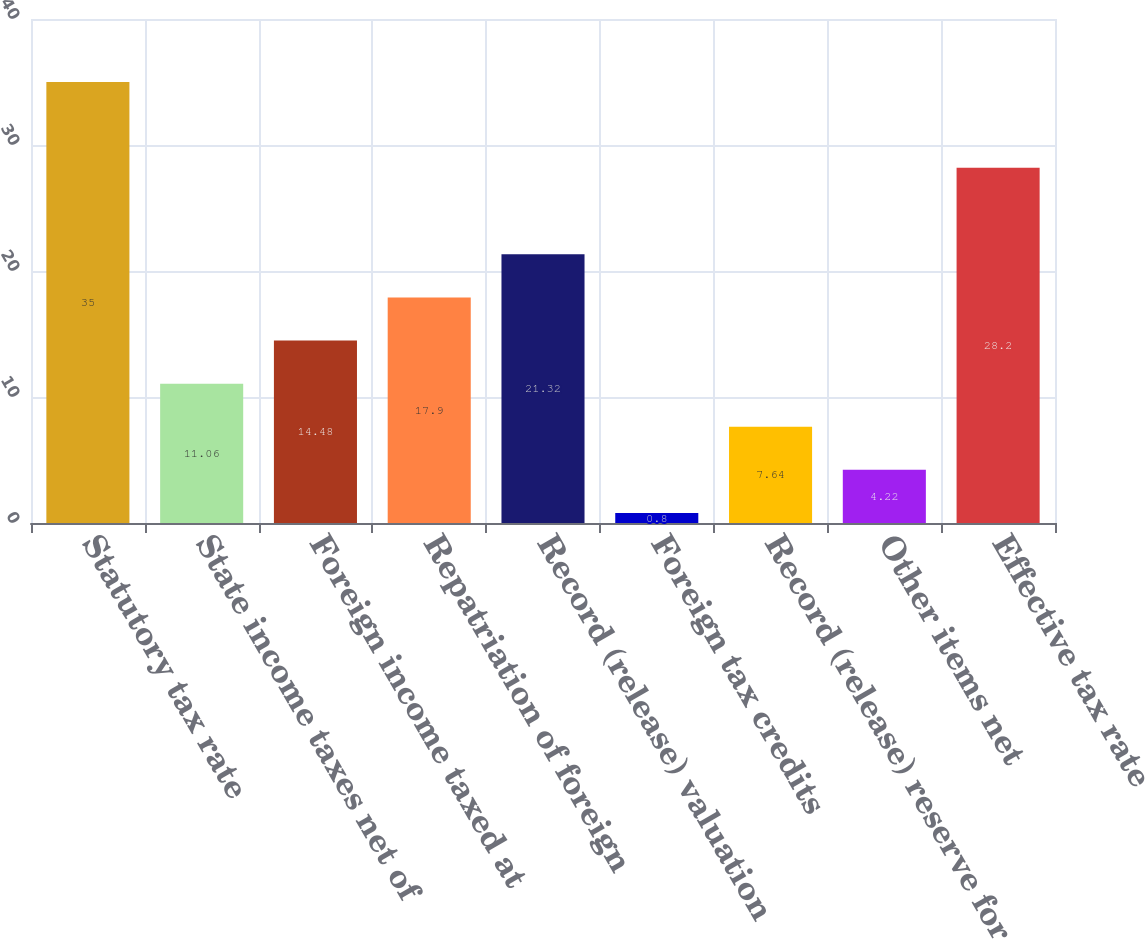<chart> <loc_0><loc_0><loc_500><loc_500><bar_chart><fcel>Statutory tax rate<fcel>State income taxes net of<fcel>Foreign income taxed at<fcel>Repatriation of foreign<fcel>Record (release) valuation<fcel>Foreign tax credits<fcel>Record (release) reserve for<fcel>Other items net<fcel>Effective tax rate<nl><fcel>35<fcel>11.06<fcel>14.48<fcel>17.9<fcel>21.32<fcel>0.8<fcel>7.64<fcel>4.22<fcel>28.2<nl></chart> 